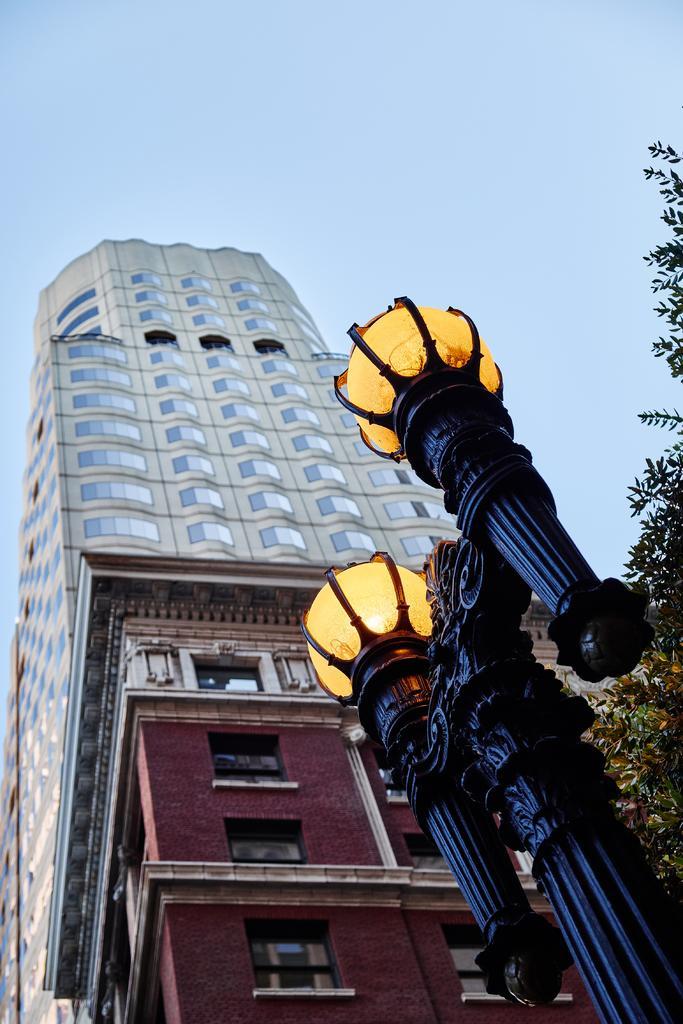Can you describe this image briefly? In this picture we can see skyscraper and building. At the bottom right there is a street light. On the right we can see trees. At the top we can see sky and clouds. 